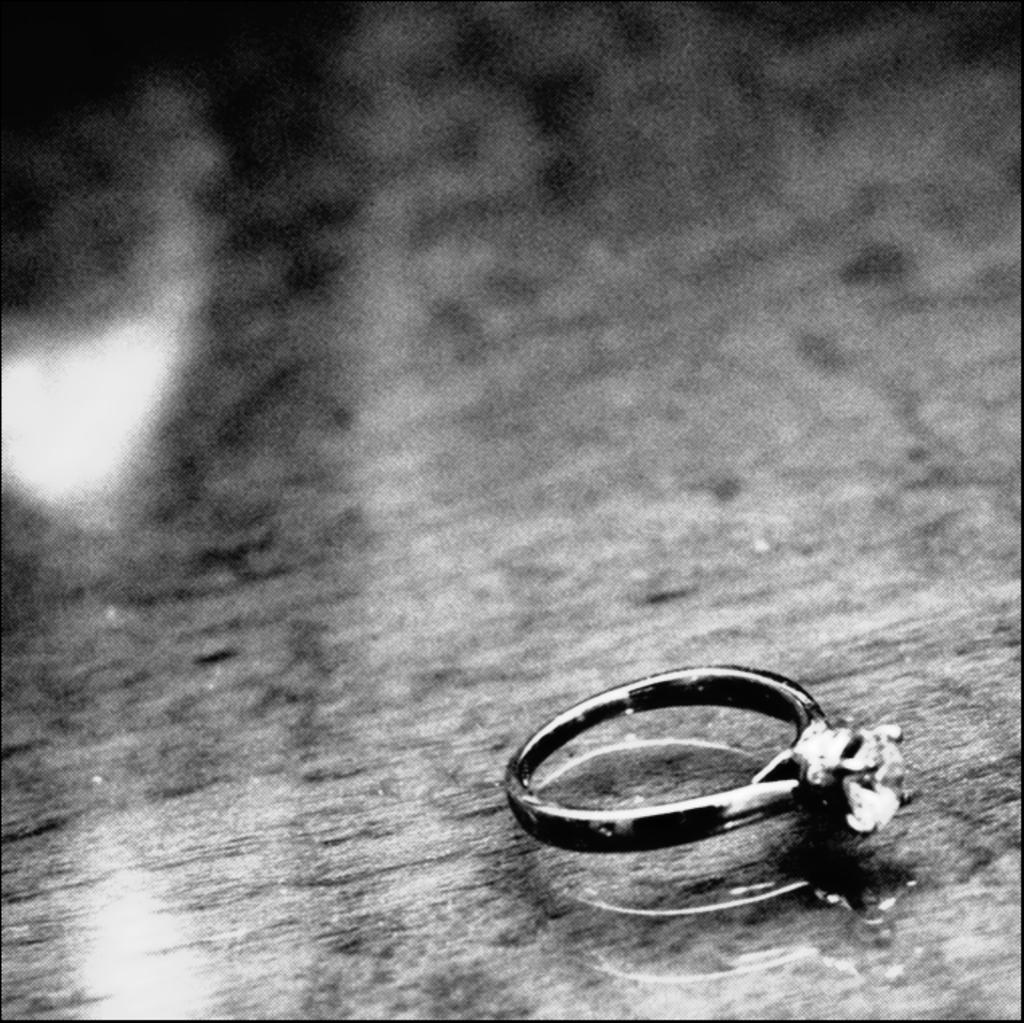What object can be seen on the surface in the image? There is a ring on the surface in the image. What color scheme is used in the image? The image is black and white. How many ladybugs are visible on the ring in the image? There are no ladybugs present in the image; it only features a ring on a black and white surface. 